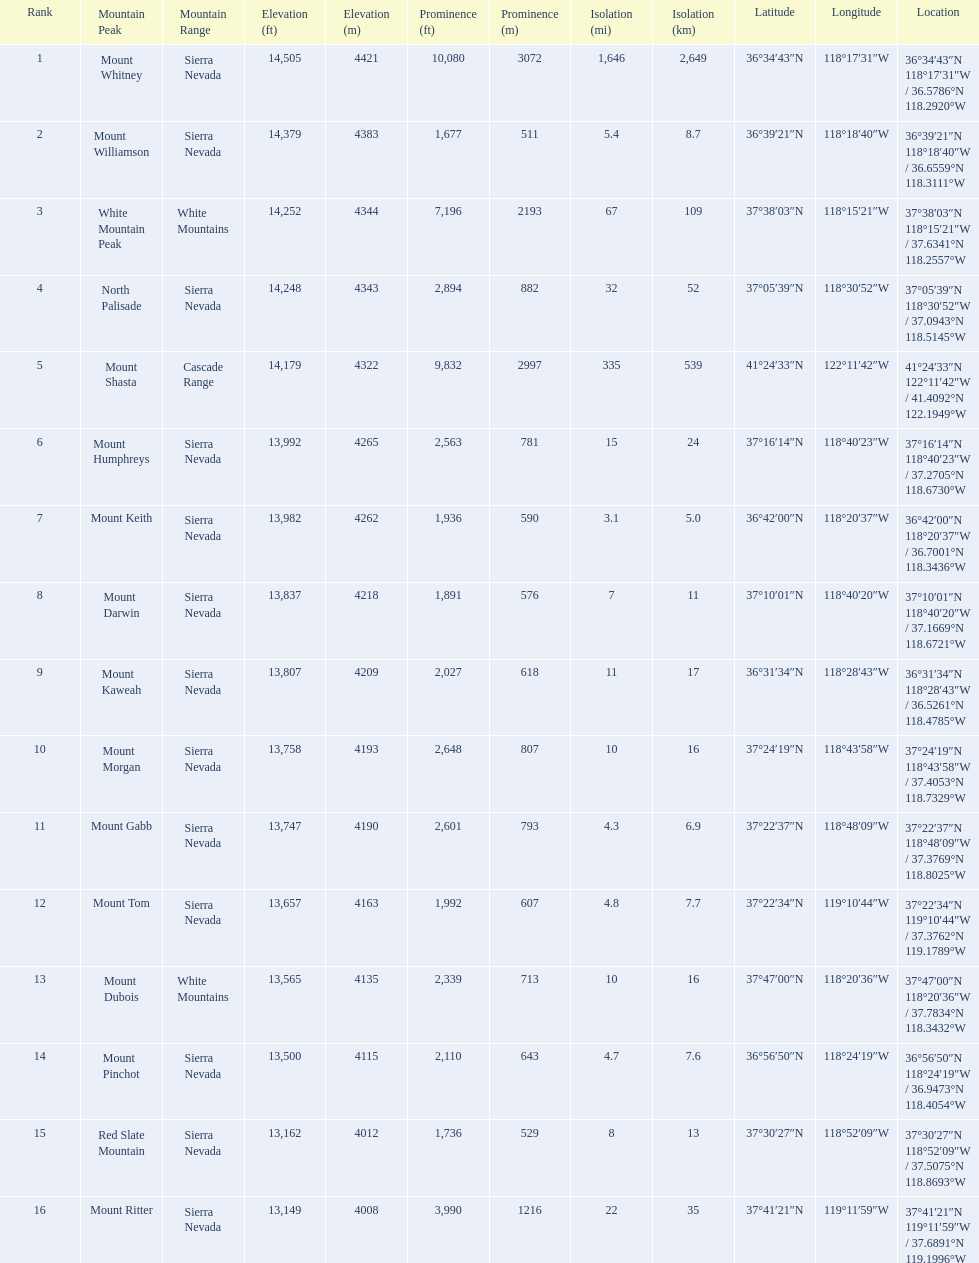Which are the highest mountain peaks in california? Mount Whitney, Mount Williamson, White Mountain Peak, North Palisade, Mount Shasta, Mount Humphreys, Mount Keith, Mount Darwin, Mount Kaweah, Mount Morgan, Mount Gabb, Mount Tom, Mount Dubois, Mount Pinchot, Red Slate Mountain, Mount Ritter. Of those, which are not in the sierra nevada range? White Mountain Peak, Mount Shasta, Mount Dubois. Of the mountains not in the sierra nevada range, which is the only mountain in the cascades? Mount Shasta. 